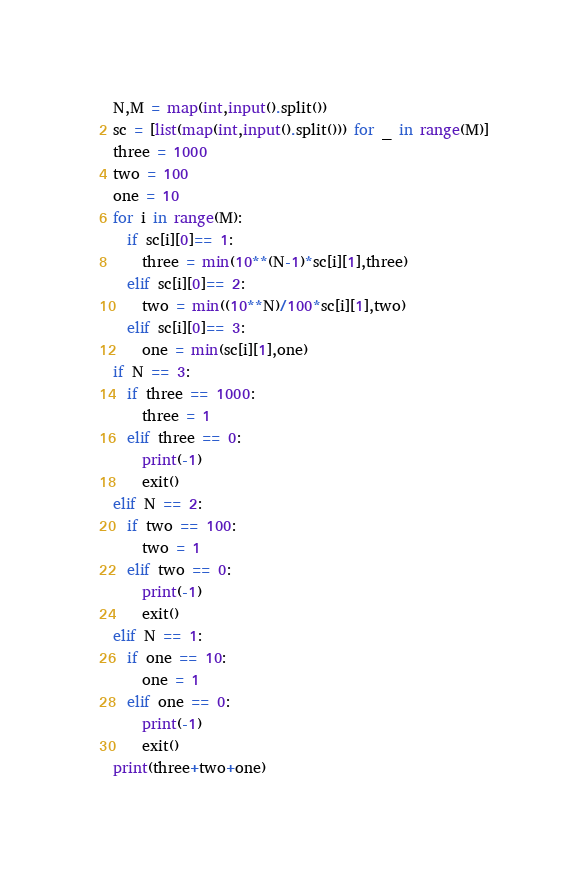Convert code to text. <code><loc_0><loc_0><loc_500><loc_500><_Python_>N,M = map(int,input().split())
sc = [list(map(int,input().split())) for _ in range(M)]
three = 1000
two = 100
one = 10
for i in range(M):
  if sc[i][0]== 1:
    three = min(10**(N-1)*sc[i][1],three)
  elif sc[i][0]== 2:
    two = min((10**N)/100*sc[i][1],two)
  elif sc[i][0]== 3:
    one = min(sc[i][1],one)
if N == 3:
  if three == 1000:
    three = 1
  elif three == 0:
    print(-1)
    exit()
elif N == 2:
  if two == 100:
    two = 1
  elif two == 0:
    print(-1)
    exit()
elif N == 1:
  if one == 10:
    one = 1
  elif one == 0:
    print(-1)
    exit()
print(three+two+one)</code> 